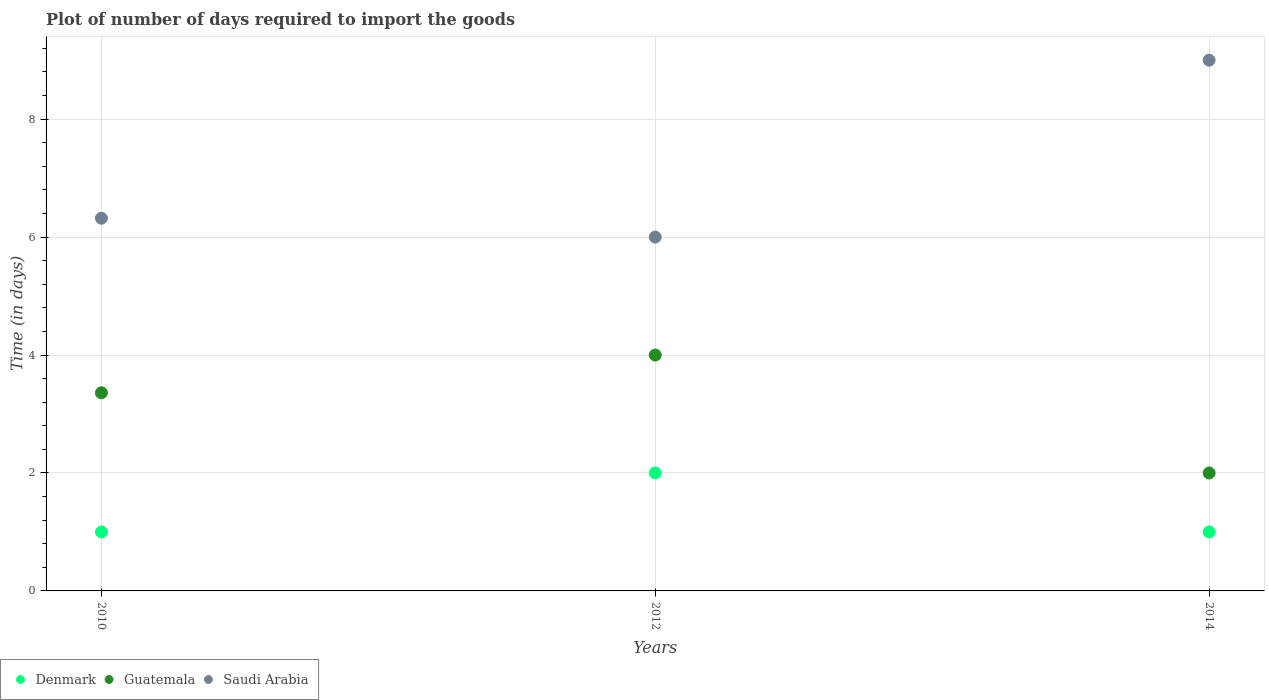How many different coloured dotlines are there?
Make the answer very short. 3. Is the number of dotlines equal to the number of legend labels?
Make the answer very short. Yes. In which year was the time required to import goods in Saudi Arabia minimum?
Your response must be concise. 2012. What is the total time required to import goods in Guatemala in the graph?
Give a very brief answer. 9.36. What is the difference between the time required to import goods in Guatemala in 2010 and that in 2014?
Ensure brevity in your answer.  1.36. What is the difference between the time required to import goods in Saudi Arabia in 2014 and the time required to import goods in Guatemala in 2010?
Provide a succinct answer. 5.64. What is the average time required to import goods in Denmark per year?
Provide a succinct answer. 1.33. In how many years, is the time required to import goods in Denmark greater than 4.4 days?
Keep it short and to the point. 0. What is the ratio of the time required to import goods in Denmark in 2010 to that in 2014?
Your response must be concise. 1. What is the difference between the highest and the lowest time required to import goods in Saudi Arabia?
Keep it short and to the point. 3. Is the sum of the time required to import goods in Saudi Arabia in 2010 and 2014 greater than the maximum time required to import goods in Guatemala across all years?
Offer a very short reply. Yes. Is the time required to import goods in Saudi Arabia strictly less than the time required to import goods in Denmark over the years?
Offer a very short reply. No. How many dotlines are there?
Provide a short and direct response. 3. What is the difference between two consecutive major ticks on the Y-axis?
Your answer should be very brief. 2. What is the title of the graph?
Your answer should be very brief. Plot of number of days required to import the goods. Does "Benin" appear as one of the legend labels in the graph?
Give a very brief answer. No. What is the label or title of the X-axis?
Provide a succinct answer. Years. What is the label or title of the Y-axis?
Offer a terse response. Time (in days). What is the Time (in days) of Denmark in 2010?
Ensure brevity in your answer.  1. What is the Time (in days) of Guatemala in 2010?
Your answer should be very brief. 3.36. What is the Time (in days) of Saudi Arabia in 2010?
Your answer should be very brief. 6.32. What is the Time (in days) in Denmark in 2012?
Your answer should be very brief. 2. What is the Time (in days) of Guatemala in 2012?
Make the answer very short. 4. What is the Time (in days) of Guatemala in 2014?
Provide a short and direct response. 2. Across all years, what is the maximum Time (in days) of Denmark?
Your response must be concise. 2. Across all years, what is the maximum Time (in days) of Guatemala?
Offer a very short reply. 4. Across all years, what is the minimum Time (in days) in Saudi Arabia?
Give a very brief answer. 6. What is the total Time (in days) in Denmark in the graph?
Make the answer very short. 4. What is the total Time (in days) of Guatemala in the graph?
Provide a short and direct response. 9.36. What is the total Time (in days) of Saudi Arabia in the graph?
Your response must be concise. 21.32. What is the difference between the Time (in days) in Denmark in 2010 and that in 2012?
Provide a short and direct response. -1. What is the difference between the Time (in days) in Guatemala in 2010 and that in 2012?
Make the answer very short. -0.64. What is the difference between the Time (in days) of Saudi Arabia in 2010 and that in 2012?
Ensure brevity in your answer.  0.32. What is the difference between the Time (in days) in Guatemala in 2010 and that in 2014?
Your answer should be very brief. 1.36. What is the difference between the Time (in days) of Saudi Arabia in 2010 and that in 2014?
Provide a short and direct response. -2.68. What is the difference between the Time (in days) of Denmark in 2012 and that in 2014?
Your response must be concise. 1. What is the difference between the Time (in days) in Saudi Arabia in 2012 and that in 2014?
Provide a short and direct response. -3. What is the difference between the Time (in days) in Denmark in 2010 and the Time (in days) in Saudi Arabia in 2012?
Offer a terse response. -5. What is the difference between the Time (in days) in Guatemala in 2010 and the Time (in days) in Saudi Arabia in 2012?
Offer a terse response. -2.64. What is the difference between the Time (in days) in Denmark in 2010 and the Time (in days) in Saudi Arabia in 2014?
Your response must be concise. -8. What is the difference between the Time (in days) of Guatemala in 2010 and the Time (in days) of Saudi Arabia in 2014?
Your response must be concise. -5.64. What is the difference between the Time (in days) of Guatemala in 2012 and the Time (in days) of Saudi Arabia in 2014?
Offer a very short reply. -5. What is the average Time (in days) of Guatemala per year?
Your answer should be compact. 3.12. What is the average Time (in days) of Saudi Arabia per year?
Keep it short and to the point. 7.11. In the year 2010, what is the difference between the Time (in days) in Denmark and Time (in days) in Guatemala?
Ensure brevity in your answer.  -2.36. In the year 2010, what is the difference between the Time (in days) in Denmark and Time (in days) in Saudi Arabia?
Make the answer very short. -5.32. In the year 2010, what is the difference between the Time (in days) of Guatemala and Time (in days) of Saudi Arabia?
Make the answer very short. -2.96. In the year 2014, what is the difference between the Time (in days) in Denmark and Time (in days) in Saudi Arabia?
Make the answer very short. -8. What is the ratio of the Time (in days) in Guatemala in 2010 to that in 2012?
Offer a terse response. 0.84. What is the ratio of the Time (in days) in Saudi Arabia in 2010 to that in 2012?
Provide a succinct answer. 1.05. What is the ratio of the Time (in days) in Guatemala in 2010 to that in 2014?
Your answer should be very brief. 1.68. What is the ratio of the Time (in days) of Saudi Arabia in 2010 to that in 2014?
Give a very brief answer. 0.7. What is the ratio of the Time (in days) of Guatemala in 2012 to that in 2014?
Make the answer very short. 2. What is the ratio of the Time (in days) of Saudi Arabia in 2012 to that in 2014?
Your answer should be very brief. 0.67. What is the difference between the highest and the second highest Time (in days) in Guatemala?
Offer a very short reply. 0.64. What is the difference between the highest and the second highest Time (in days) in Saudi Arabia?
Your answer should be very brief. 2.68. 